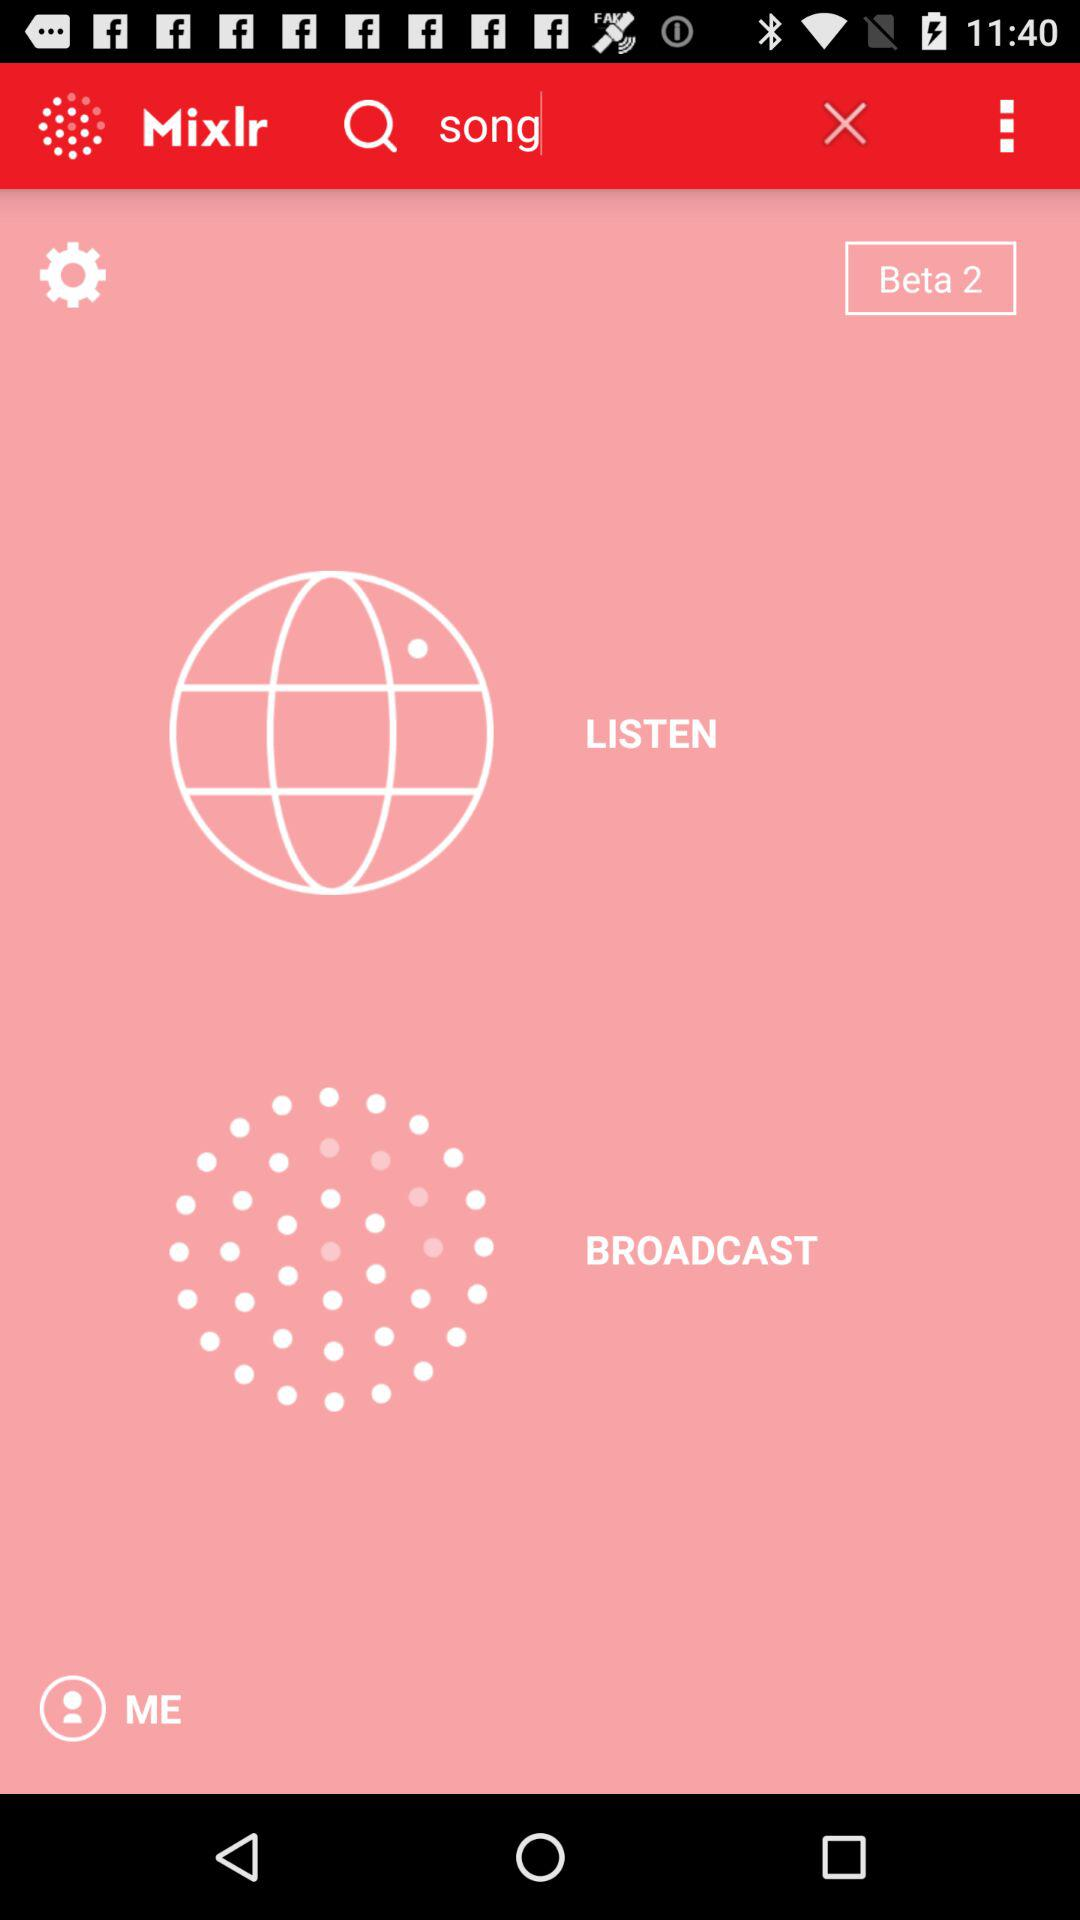What is the application name? The application name is "Mixlr". 